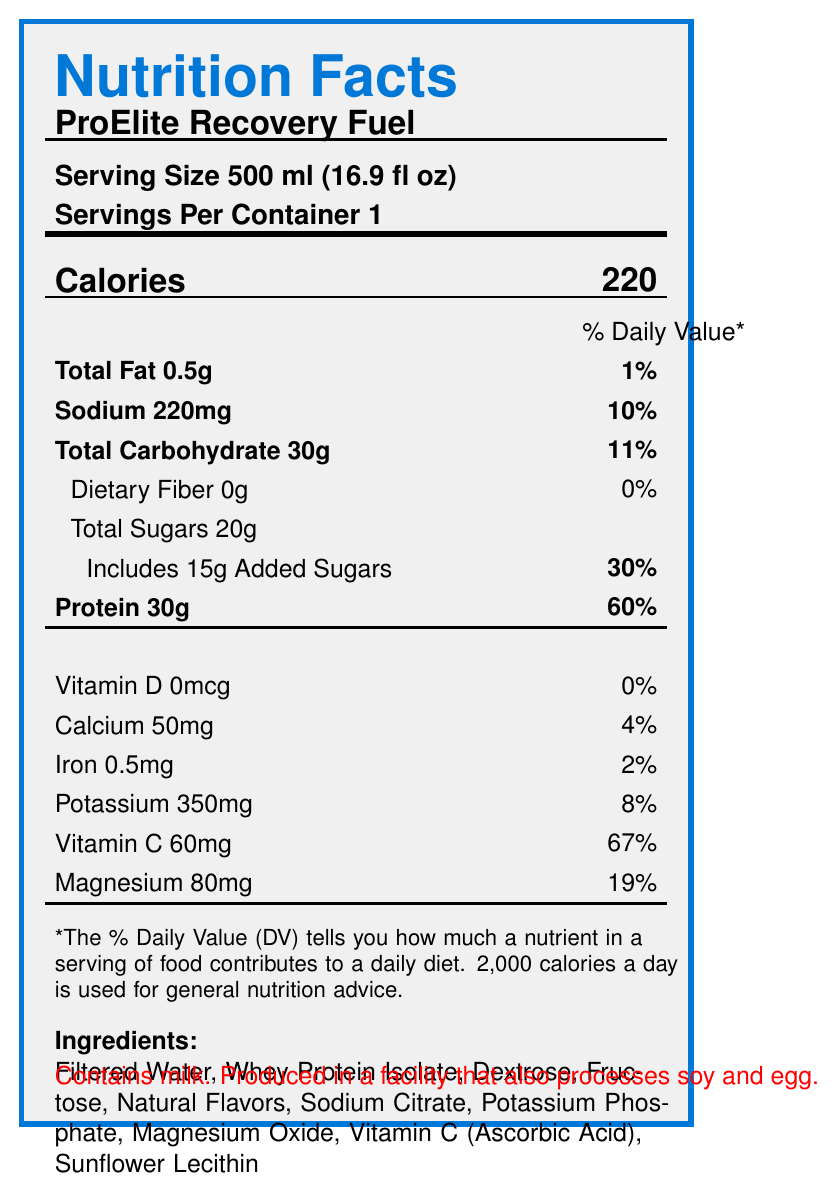what is the serving size for ProElite Recovery Fuel? The serving size is provided directly in the document under "Serving Size".
Answer: 500 ml (16.9 fl oz) how many calories are in one serving of ProElite Recovery Fuel? The Calories section lists 220 calories for one serving.
Answer: 220 what percentage of the daily value for protein does one serving of ProElite Recovery Fuel provide? The protein section indicates that one serving provides 60% of the daily value.
Answer: 60% how much total fat is in one serving of ProElite Recovery Fuel? The total fat content is listed as 0.5g.
Answer: 0.5g how much sodium is in one serving? The sodium content is provided as 220mg.
Answer: 220mg what is the main source of protein in ProElite Recovery Fuel? The ingredients list shows that Whey Protein Isolate is the main source of protein.
Answer: Whey Protein Isolate how many grams of added sugars are in one serving? The total sugars section indicates that there are 20g of total sugars, including 15g of added sugars.
Answer: 15g what is the purpose of taking ProElite Recovery Fuel? The recommended use statement at the bottom of the document specifies this.
Answer: Consume immediately after your workout for optimal recovery and to maintain your competitive edge. what benefits does ProElite Recovery Fuel offer for post-workout recovery? The document lists specific recovery benefits provided by ProElite Recovery Fuel.
Answer: 30g of fast-absorbing protein, balanced carbohydrates for quick energy, electrolytes, added vitamin C. what allergens are contained in ProElite Recovery Fuel? The allergen information section clearly states that the product contains milk.
Answer: Contains milk. which of the following vitamins is present in ProElite Recovery Fuel? A. Vitamin A B. Vitamin B12 C. Vitamin C D. Vitamin K The vitamin C content is 60mg, as listed in the nutrient section.
Answer: C. Vitamin C what percentage of the daily value of Vitamin C is in one serving? A. 25% B. 50% C. 67% D. 90% The document lists Vitamin C content as 60mg, which corresponds to 67% of the daily value.
Answer: C. 67% does ProElite Recovery Fuel provide any dietary fiber? The document lists dietary fiber content as 0g and 0% daily value.
Answer: No describe the main idea of the document. The document combines all essential details about the nutrition facts, composition, benefits, and usage of the product.
Answer: The document provides detailed nutritional information for ProElite Recovery Fuel, a high-protein sports drink designed for post-workout recovery. It includes serving size, calories, nutrient amounts and daily values, ingredients, recovery benefits, allergen information, and recommended use instructions. what is the cost of one container of ProElite Recovery Fuel? The document does not provide information about the cost.
Answer: Cannot be determined 